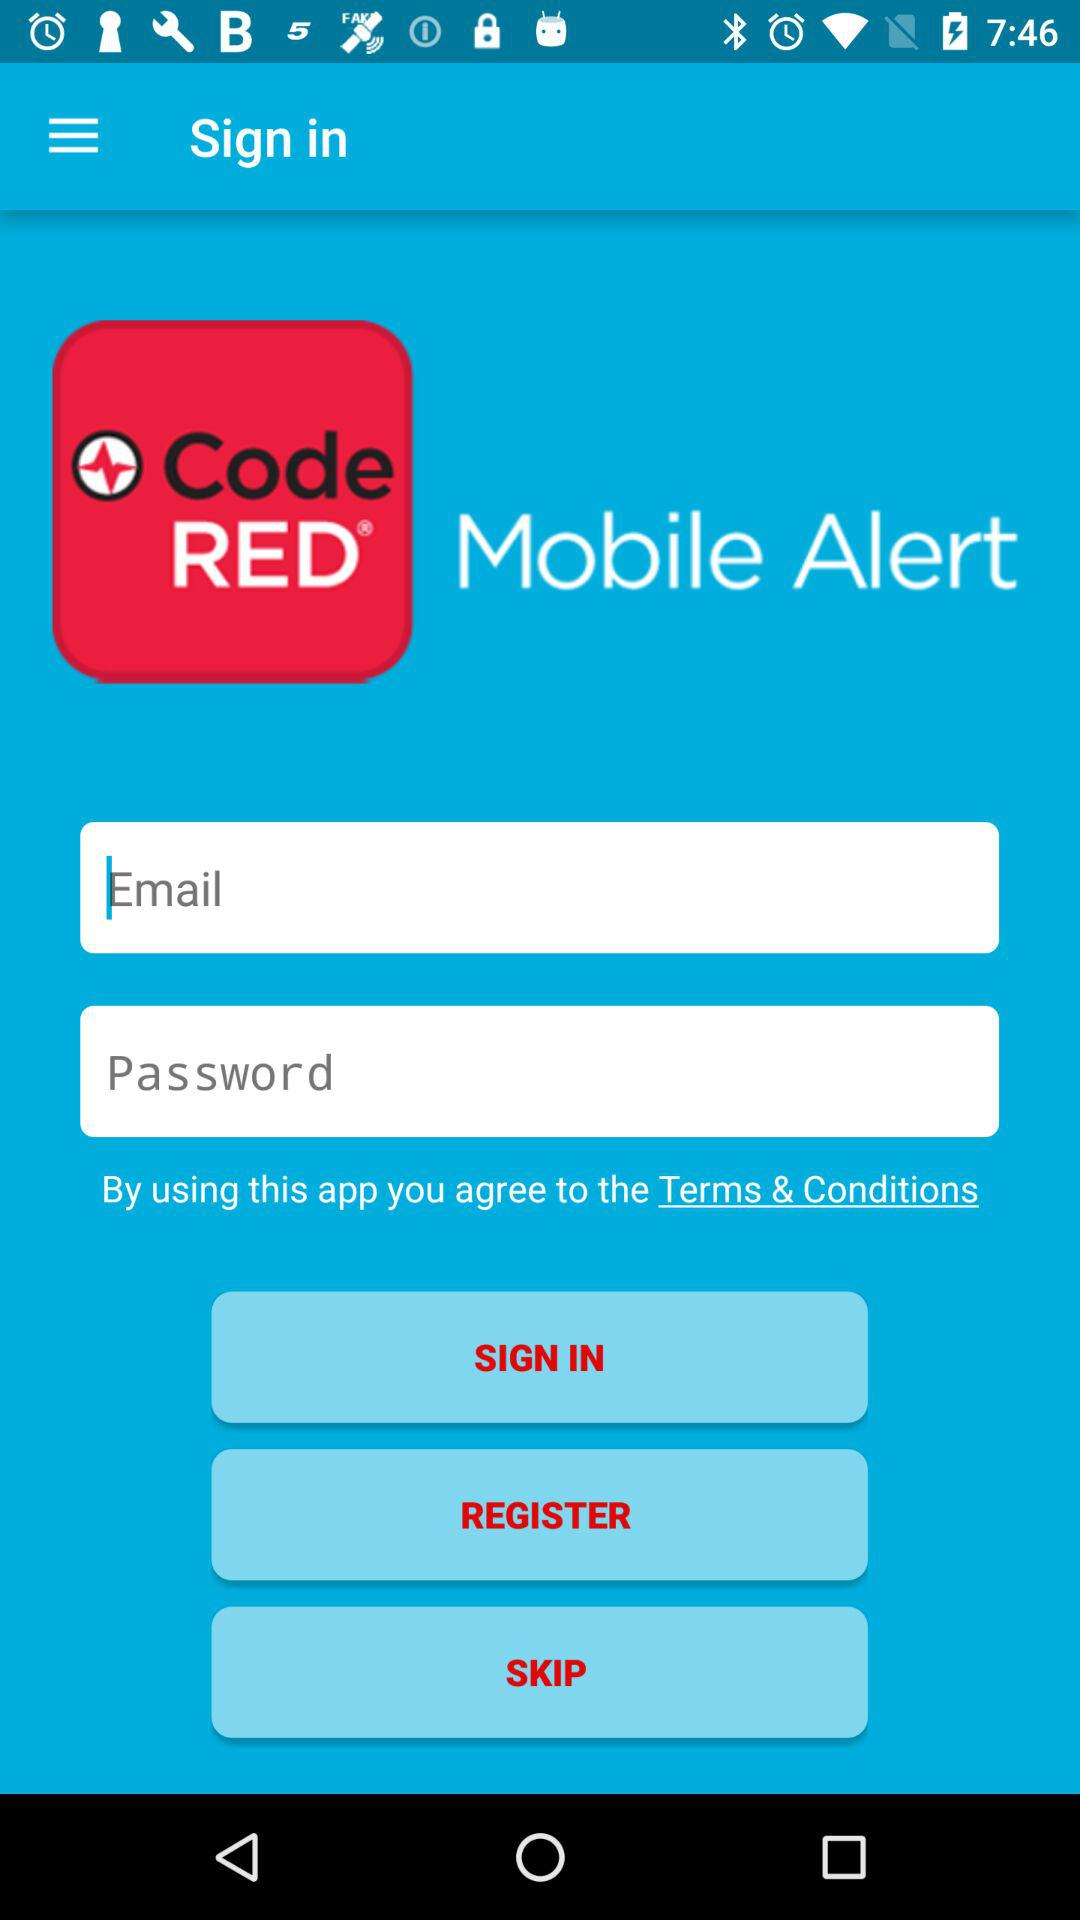What is the name of application? The name of application is "Code RED Mobile Alert". 